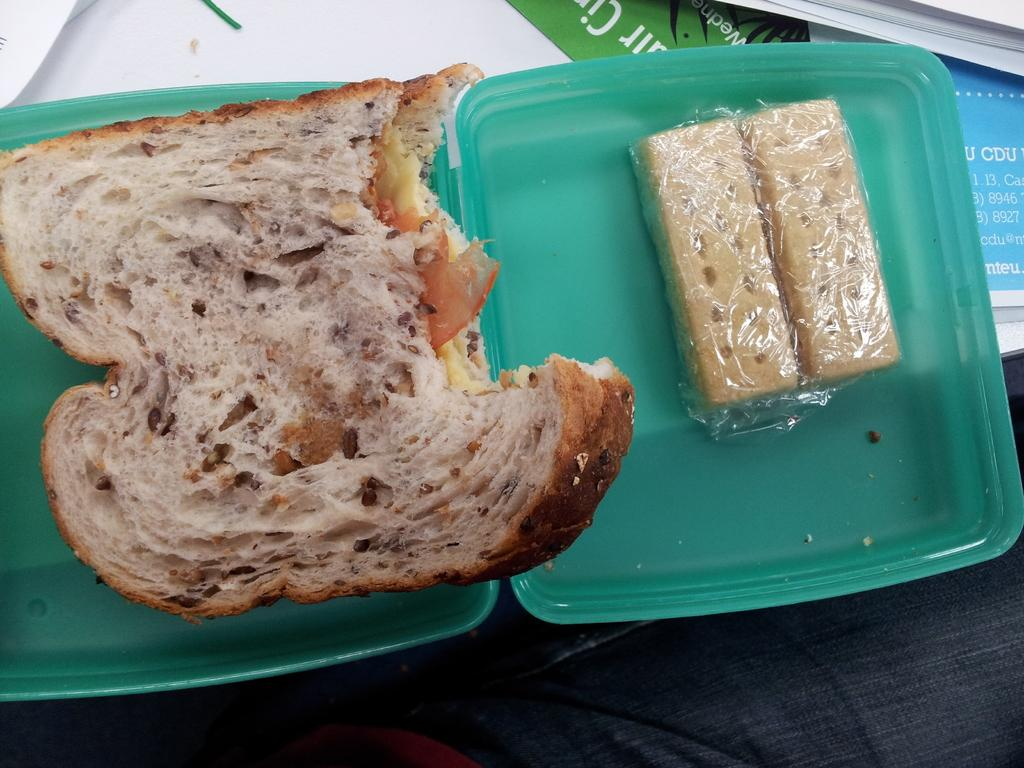What is contained in the box that is visible in the image? There is food in a box in the image. What other items can be seen in the image besides the food in the box? There are papers visible in the image. What type of stew is being served at the meeting in the image? There is no stew or meeting present in the image; it only features food in a box and papers. What type of tank is visible in the image? There is no tank present in the image. 